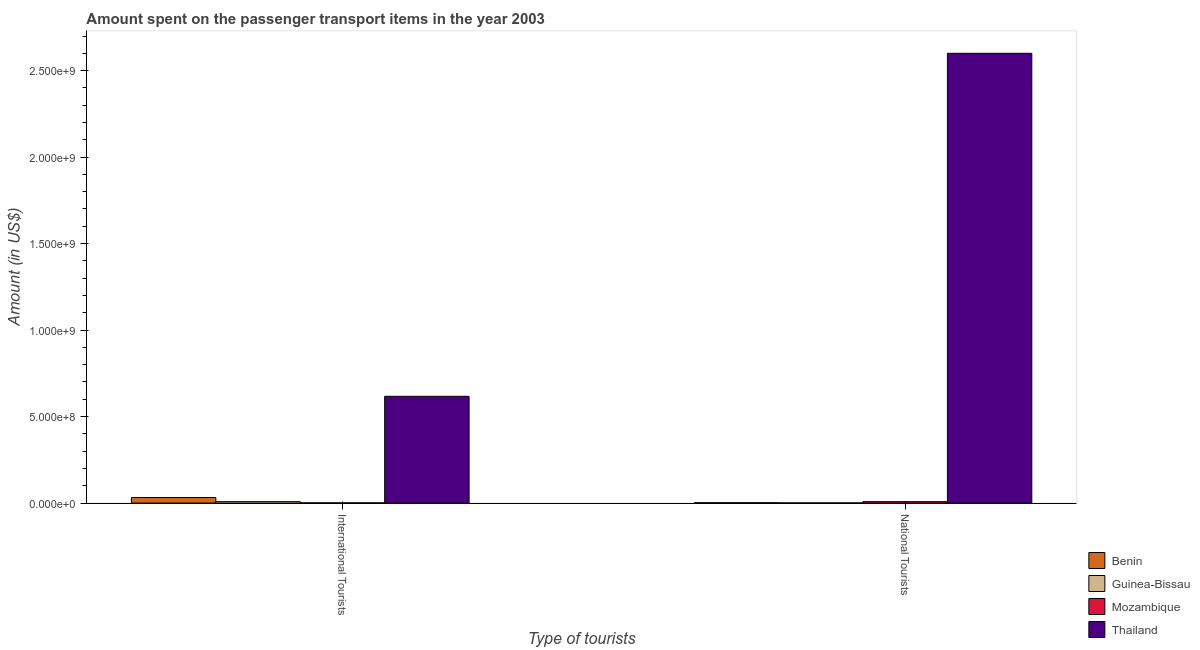How many groups of bars are there?
Your answer should be very brief. 2. What is the label of the 1st group of bars from the left?
Your answer should be very brief. International Tourists. What is the amount spent on transport items of national tourists in Benin?
Keep it short and to the point. 1.90e+06. Across all countries, what is the maximum amount spent on transport items of national tourists?
Provide a succinct answer. 2.60e+09. Across all countries, what is the minimum amount spent on transport items of national tourists?
Make the answer very short. 6.00e+05. In which country was the amount spent on transport items of national tourists maximum?
Offer a very short reply. Thailand. In which country was the amount spent on transport items of national tourists minimum?
Your answer should be very brief. Guinea-Bissau. What is the total amount spent on transport items of national tourists in the graph?
Give a very brief answer. 2.61e+09. What is the difference between the amount spent on transport items of national tourists in Thailand and that in Guinea-Bissau?
Provide a succinct answer. 2.60e+09. What is the difference between the amount spent on transport items of international tourists in Guinea-Bissau and the amount spent on transport items of national tourists in Thailand?
Keep it short and to the point. -2.59e+09. What is the average amount spent on transport items of international tourists per country?
Offer a terse response. 1.64e+08. What is the difference between the amount spent on transport items of international tourists and amount spent on transport items of national tourists in Mozambique?
Make the answer very short. -7.00e+06. In how many countries, is the amount spent on transport items of national tourists greater than 900000000 US$?
Make the answer very short. 1. Is the amount spent on transport items of international tourists in Guinea-Bissau less than that in Benin?
Offer a terse response. Yes. In how many countries, is the amount spent on transport items of international tourists greater than the average amount spent on transport items of international tourists taken over all countries?
Your response must be concise. 1. What does the 3rd bar from the left in National Tourists represents?
Your answer should be very brief. Mozambique. What does the 1st bar from the right in National Tourists represents?
Your answer should be compact. Thailand. How many bars are there?
Ensure brevity in your answer.  8. Does the graph contain grids?
Your answer should be compact. No. How are the legend labels stacked?
Your answer should be very brief. Vertical. What is the title of the graph?
Your answer should be very brief. Amount spent on the passenger transport items in the year 2003. What is the label or title of the X-axis?
Your answer should be very brief. Type of tourists. What is the label or title of the Y-axis?
Give a very brief answer. Amount (in US$). What is the Amount (in US$) in Benin in International Tourists?
Keep it short and to the point. 3.20e+07. What is the Amount (in US$) in Mozambique in International Tourists?
Keep it short and to the point. 1.00e+06. What is the Amount (in US$) of Thailand in International Tourists?
Your answer should be compact. 6.17e+08. What is the Amount (in US$) of Benin in National Tourists?
Provide a short and direct response. 1.90e+06. What is the Amount (in US$) of Guinea-Bissau in National Tourists?
Your answer should be compact. 6.00e+05. What is the Amount (in US$) of Thailand in National Tourists?
Provide a succinct answer. 2.60e+09. Across all Type of tourists, what is the maximum Amount (in US$) in Benin?
Offer a terse response. 3.20e+07. Across all Type of tourists, what is the maximum Amount (in US$) of Guinea-Bissau?
Make the answer very short. 8.00e+06. Across all Type of tourists, what is the maximum Amount (in US$) in Thailand?
Offer a very short reply. 2.60e+09. Across all Type of tourists, what is the minimum Amount (in US$) of Benin?
Ensure brevity in your answer.  1.90e+06. Across all Type of tourists, what is the minimum Amount (in US$) in Thailand?
Make the answer very short. 6.17e+08. What is the total Amount (in US$) of Benin in the graph?
Offer a very short reply. 3.39e+07. What is the total Amount (in US$) of Guinea-Bissau in the graph?
Your response must be concise. 8.60e+06. What is the total Amount (in US$) in Mozambique in the graph?
Provide a short and direct response. 9.00e+06. What is the total Amount (in US$) of Thailand in the graph?
Your answer should be very brief. 3.22e+09. What is the difference between the Amount (in US$) in Benin in International Tourists and that in National Tourists?
Give a very brief answer. 3.01e+07. What is the difference between the Amount (in US$) in Guinea-Bissau in International Tourists and that in National Tourists?
Keep it short and to the point. 7.40e+06. What is the difference between the Amount (in US$) in Mozambique in International Tourists and that in National Tourists?
Offer a very short reply. -7.00e+06. What is the difference between the Amount (in US$) in Thailand in International Tourists and that in National Tourists?
Provide a succinct answer. -1.98e+09. What is the difference between the Amount (in US$) in Benin in International Tourists and the Amount (in US$) in Guinea-Bissau in National Tourists?
Ensure brevity in your answer.  3.14e+07. What is the difference between the Amount (in US$) of Benin in International Tourists and the Amount (in US$) of Mozambique in National Tourists?
Ensure brevity in your answer.  2.40e+07. What is the difference between the Amount (in US$) of Benin in International Tourists and the Amount (in US$) of Thailand in National Tourists?
Make the answer very short. -2.57e+09. What is the difference between the Amount (in US$) in Guinea-Bissau in International Tourists and the Amount (in US$) in Mozambique in National Tourists?
Provide a succinct answer. 0. What is the difference between the Amount (in US$) of Guinea-Bissau in International Tourists and the Amount (in US$) of Thailand in National Tourists?
Offer a very short reply. -2.59e+09. What is the difference between the Amount (in US$) of Mozambique in International Tourists and the Amount (in US$) of Thailand in National Tourists?
Give a very brief answer. -2.60e+09. What is the average Amount (in US$) of Benin per Type of tourists?
Provide a short and direct response. 1.70e+07. What is the average Amount (in US$) of Guinea-Bissau per Type of tourists?
Offer a terse response. 4.30e+06. What is the average Amount (in US$) of Mozambique per Type of tourists?
Your response must be concise. 4.50e+06. What is the average Amount (in US$) in Thailand per Type of tourists?
Offer a terse response. 1.61e+09. What is the difference between the Amount (in US$) in Benin and Amount (in US$) in Guinea-Bissau in International Tourists?
Your response must be concise. 2.40e+07. What is the difference between the Amount (in US$) of Benin and Amount (in US$) of Mozambique in International Tourists?
Your answer should be very brief. 3.10e+07. What is the difference between the Amount (in US$) of Benin and Amount (in US$) of Thailand in International Tourists?
Keep it short and to the point. -5.85e+08. What is the difference between the Amount (in US$) in Guinea-Bissau and Amount (in US$) in Thailand in International Tourists?
Provide a short and direct response. -6.09e+08. What is the difference between the Amount (in US$) in Mozambique and Amount (in US$) in Thailand in International Tourists?
Your answer should be very brief. -6.16e+08. What is the difference between the Amount (in US$) of Benin and Amount (in US$) of Guinea-Bissau in National Tourists?
Keep it short and to the point. 1.30e+06. What is the difference between the Amount (in US$) of Benin and Amount (in US$) of Mozambique in National Tourists?
Offer a very short reply. -6.10e+06. What is the difference between the Amount (in US$) in Benin and Amount (in US$) in Thailand in National Tourists?
Make the answer very short. -2.60e+09. What is the difference between the Amount (in US$) of Guinea-Bissau and Amount (in US$) of Mozambique in National Tourists?
Give a very brief answer. -7.40e+06. What is the difference between the Amount (in US$) in Guinea-Bissau and Amount (in US$) in Thailand in National Tourists?
Offer a very short reply. -2.60e+09. What is the difference between the Amount (in US$) of Mozambique and Amount (in US$) of Thailand in National Tourists?
Offer a very short reply. -2.59e+09. What is the ratio of the Amount (in US$) in Benin in International Tourists to that in National Tourists?
Keep it short and to the point. 16.84. What is the ratio of the Amount (in US$) of Guinea-Bissau in International Tourists to that in National Tourists?
Make the answer very short. 13.33. What is the ratio of the Amount (in US$) of Mozambique in International Tourists to that in National Tourists?
Keep it short and to the point. 0.12. What is the ratio of the Amount (in US$) in Thailand in International Tourists to that in National Tourists?
Provide a short and direct response. 0.24. What is the difference between the highest and the second highest Amount (in US$) of Benin?
Give a very brief answer. 3.01e+07. What is the difference between the highest and the second highest Amount (in US$) in Guinea-Bissau?
Ensure brevity in your answer.  7.40e+06. What is the difference between the highest and the second highest Amount (in US$) in Mozambique?
Your response must be concise. 7.00e+06. What is the difference between the highest and the second highest Amount (in US$) of Thailand?
Offer a very short reply. 1.98e+09. What is the difference between the highest and the lowest Amount (in US$) of Benin?
Your response must be concise. 3.01e+07. What is the difference between the highest and the lowest Amount (in US$) in Guinea-Bissau?
Offer a very short reply. 7.40e+06. What is the difference between the highest and the lowest Amount (in US$) in Thailand?
Give a very brief answer. 1.98e+09. 